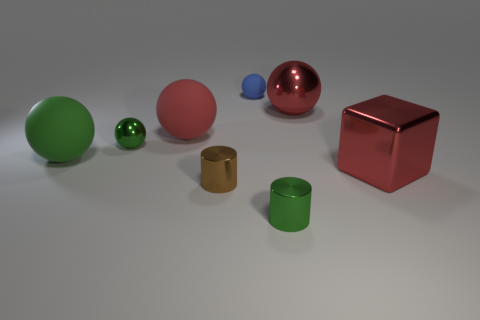Subtract all red rubber spheres. How many spheres are left? 4 Subtract all big purple metallic objects. Subtract all red objects. How many objects are left? 5 Add 6 small rubber spheres. How many small rubber spheres are left? 7 Add 6 big gray shiny things. How many big gray shiny things exist? 6 Add 1 purple cubes. How many objects exist? 9 Subtract all green cylinders. How many cylinders are left? 1 Subtract 1 red balls. How many objects are left? 7 Subtract all cubes. How many objects are left? 7 Subtract 1 blocks. How many blocks are left? 0 Subtract all gray spheres. Subtract all brown blocks. How many spheres are left? 5 